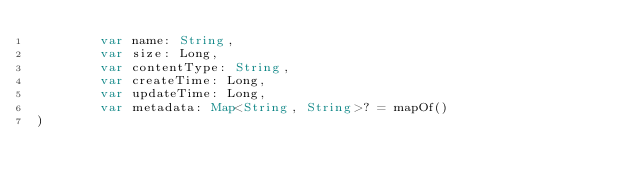<code> <loc_0><loc_0><loc_500><loc_500><_Kotlin_>        var name: String,
        var size: Long,
        var contentType: String,
        var createTime: Long,
        var updateTime: Long,
        var metadata: Map<String, String>? = mapOf()
)</code> 